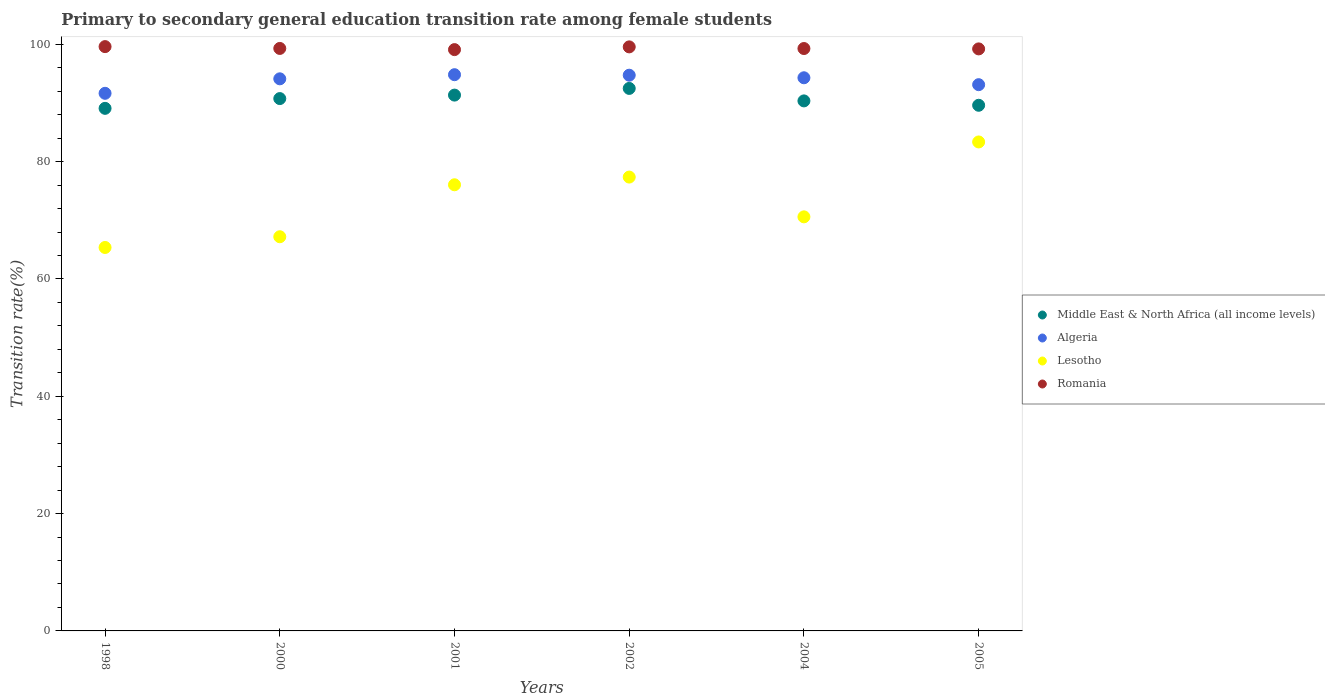What is the transition rate in Lesotho in 2000?
Your answer should be very brief. 67.2. Across all years, what is the maximum transition rate in Middle East & North Africa (all income levels)?
Keep it short and to the point. 92.48. Across all years, what is the minimum transition rate in Middle East & North Africa (all income levels)?
Keep it short and to the point. 89.09. In which year was the transition rate in Algeria maximum?
Give a very brief answer. 2001. In which year was the transition rate in Middle East & North Africa (all income levels) minimum?
Give a very brief answer. 1998. What is the total transition rate in Romania in the graph?
Your answer should be very brief. 596.08. What is the difference between the transition rate in Lesotho in 2001 and that in 2004?
Ensure brevity in your answer.  5.47. What is the difference between the transition rate in Algeria in 1998 and the transition rate in Romania in 2001?
Provide a short and direct response. -7.45. What is the average transition rate in Lesotho per year?
Your response must be concise. 73.32. In the year 2004, what is the difference between the transition rate in Romania and transition rate in Algeria?
Your answer should be very brief. 4.99. What is the ratio of the transition rate in Algeria in 1998 to that in 2000?
Ensure brevity in your answer.  0.97. Is the transition rate in Lesotho in 1998 less than that in 2005?
Your answer should be compact. Yes. What is the difference between the highest and the second highest transition rate in Algeria?
Provide a short and direct response. 0.09. What is the difference between the highest and the lowest transition rate in Lesotho?
Give a very brief answer. 17.99. In how many years, is the transition rate in Middle East & North Africa (all income levels) greater than the average transition rate in Middle East & North Africa (all income levels) taken over all years?
Offer a very short reply. 3. Is it the case that in every year, the sum of the transition rate in Algeria and transition rate in Romania  is greater than the sum of transition rate in Lesotho and transition rate in Middle East & North Africa (all income levels)?
Your response must be concise. Yes. Does the transition rate in Lesotho monotonically increase over the years?
Make the answer very short. No. Is the transition rate in Algeria strictly less than the transition rate in Middle East & North Africa (all income levels) over the years?
Ensure brevity in your answer.  No. How many dotlines are there?
Provide a short and direct response. 4. Does the graph contain grids?
Give a very brief answer. No. Where does the legend appear in the graph?
Your response must be concise. Center right. What is the title of the graph?
Ensure brevity in your answer.  Primary to secondary general education transition rate among female students. Does "Brunei Darussalam" appear as one of the legend labels in the graph?
Your response must be concise. No. What is the label or title of the X-axis?
Offer a terse response. Years. What is the label or title of the Y-axis?
Provide a succinct answer. Transition rate(%). What is the Transition rate(%) of Middle East & North Africa (all income levels) in 1998?
Provide a short and direct response. 89.09. What is the Transition rate(%) of Algeria in 1998?
Offer a terse response. 91.65. What is the Transition rate(%) of Lesotho in 1998?
Offer a very short reply. 65.37. What is the Transition rate(%) in Romania in 1998?
Keep it short and to the point. 99.61. What is the Transition rate(%) in Middle East & North Africa (all income levels) in 2000?
Provide a succinct answer. 90.75. What is the Transition rate(%) in Algeria in 2000?
Your response must be concise. 94.12. What is the Transition rate(%) in Lesotho in 2000?
Provide a succinct answer. 67.2. What is the Transition rate(%) of Romania in 2000?
Keep it short and to the point. 99.3. What is the Transition rate(%) of Middle East & North Africa (all income levels) in 2001?
Provide a succinct answer. 91.34. What is the Transition rate(%) of Algeria in 2001?
Provide a short and direct response. 94.82. What is the Transition rate(%) in Lesotho in 2001?
Provide a short and direct response. 76.06. What is the Transition rate(%) in Romania in 2001?
Your response must be concise. 99.1. What is the Transition rate(%) of Middle East & North Africa (all income levels) in 2002?
Your response must be concise. 92.48. What is the Transition rate(%) of Algeria in 2002?
Your response must be concise. 94.74. What is the Transition rate(%) in Lesotho in 2002?
Ensure brevity in your answer.  77.37. What is the Transition rate(%) in Romania in 2002?
Your response must be concise. 99.56. What is the Transition rate(%) in Middle East & North Africa (all income levels) in 2004?
Your response must be concise. 90.36. What is the Transition rate(%) in Algeria in 2004?
Give a very brief answer. 94.3. What is the Transition rate(%) in Lesotho in 2004?
Make the answer very short. 70.59. What is the Transition rate(%) of Romania in 2004?
Your answer should be compact. 99.28. What is the Transition rate(%) in Middle East & North Africa (all income levels) in 2005?
Provide a succinct answer. 89.61. What is the Transition rate(%) of Algeria in 2005?
Ensure brevity in your answer.  93.12. What is the Transition rate(%) of Lesotho in 2005?
Offer a very short reply. 83.36. What is the Transition rate(%) in Romania in 2005?
Provide a short and direct response. 99.22. Across all years, what is the maximum Transition rate(%) in Middle East & North Africa (all income levels)?
Offer a terse response. 92.48. Across all years, what is the maximum Transition rate(%) of Algeria?
Make the answer very short. 94.82. Across all years, what is the maximum Transition rate(%) in Lesotho?
Provide a short and direct response. 83.36. Across all years, what is the maximum Transition rate(%) of Romania?
Provide a short and direct response. 99.61. Across all years, what is the minimum Transition rate(%) in Middle East & North Africa (all income levels)?
Offer a very short reply. 89.09. Across all years, what is the minimum Transition rate(%) of Algeria?
Ensure brevity in your answer.  91.65. Across all years, what is the minimum Transition rate(%) in Lesotho?
Provide a succinct answer. 65.37. Across all years, what is the minimum Transition rate(%) of Romania?
Keep it short and to the point. 99.1. What is the total Transition rate(%) of Middle East & North Africa (all income levels) in the graph?
Your response must be concise. 543.64. What is the total Transition rate(%) of Algeria in the graph?
Your response must be concise. 562.75. What is the total Transition rate(%) of Lesotho in the graph?
Ensure brevity in your answer.  439.94. What is the total Transition rate(%) in Romania in the graph?
Provide a succinct answer. 596.08. What is the difference between the Transition rate(%) of Middle East & North Africa (all income levels) in 1998 and that in 2000?
Your answer should be compact. -1.66. What is the difference between the Transition rate(%) in Algeria in 1998 and that in 2000?
Offer a terse response. -2.47. What is the difference between the Transition rate(%) in Lesotho in 1998 and that in 2000?
Offer a very short reply. -1.83. What is the difference between the Transition rate(%) of Romania in 1998 and that in 2000?
Your answer should be very brief. 0.31. What is the difference between the Transition rate(%) in Middle East & North Africa (all income levels) in 1998 and that in 2001?
Your answer should be compact. -2.26. What is the difference between the Transition rate(%) in Algeria in 1998 and that in 2001?
Your response must be concise. -3.17. What is the difference between the Transition rate(%) in Lesotho in 1998 and that in 2001?
Your response must be concise. -10.69. What is the difference between the Transition rate(%) in Romania in 1998 and that in 2001?
Ensure brevity in your answer.  0.51. What is the difference between the Transition rate(%) of Middle East & North Africa (all income levels) in 1998 and that in 2002?
Give a very brief answer. -3.4. What is the difference between the Transition rate(%) of Algeria in 1998 and that in 2002?
Provide a short and direct response. -3.09. What is the difference between the Transition rate(%) of Lesotho in 1998 and that in 2002?
Your answer should be very brief. -12. What is the difference between the Transition rate(%) in Romania in 1998 and that in 2002?
Offer a very short reply. 0.05. What is the difference between the Transition rate(%) of Middle East & North Africa (all income levels) in 1998 and that in 2004?
Provide a short and direct response. -1.27. What is the difference between the Transition rate(%) in Algeria in 1998 and that in 2004?
Provide a succinct answer. -2.65. What is the difference between the Transition rate(%) of Lesotho in 1998 and that in 2004?
Offer a very short reply. -5.22. What is the difference between the Transition rate(%) in Romania in 1998 and that in 2004?
Provide a short and direct response. 0.33. What is the difference between the Transition rate(%) in Middle East & North Africa (all income levels) in 1998 and that in 2005?
Offer a terse response. -0.52. What is the difference between the Transition rate(%) of Algeria in 1998 and that in 2005?
Keep it short and to the point. -1.47. What is the difference between the Transition rate(%) of Lesotho in 1998 and that in 2005?
Make the answer very short. -17.99. What is the difference between the Transition rate(%) of Romania in 1998 and that in 2005?
Your answer should be compact. 0.39. What is the difference between the Transition rate(%) in Middle East & North Africa (all income levels) in 2000 and that in 2001?
Ensure brevity in your answer.  -0.59. What is the difference between the Transition rate(%) of Algeria in 2000 and that in 2001?
Offer a very short reply. -0.7. What is the difference between the Transition rate(%) of Lesotho in 2000 and that in 2001?
Provide a short and direct response. -8.86. What is the difference between the Transition rate(%) of Romania in 2000 and that in 2001?
Give a very brief answer. 0.2. What is the difference between the Transition rate(%) in Middle East & North Africa (all income levels) in 2000 and that in 2002?
Keep it short and to the point. -1.73. What is the difference between the Transition rate(%) in Algeria in 2000 and that in 2002?
Your answer should be very brief. -0.62. What is the difference between the Transition rate(%) in Lesotho in 2000 and that in 2002?
Your answer should be very brief. -10.17. What is the difference between the Transition rate(%) in Romania in 2000 and that in 2002?
Offer a very short reply. -0.26. What is the difference between the Transition rate(%) in Middle East & North Africa (all income levels) in 2000 and that in 2004?
Your answer should be very brief. 0.39. What is the difference between the Transition rate(%) of Algeria in 2000 and that in 2004?
Offer a terse response. -0.18. What is the difference between the Transition rate(%) of Lesotho in 2000 and that in 2004?
Your answer should be very brief. -3.39. What is the difference between the Transition rate(%) in Romania in 2000 and that in 2004?
Offer a very short reply. 0.02. What is the difference between the Transition rate(%) of Middle East & North Africa (all income levels) in 2000 and that in 2005?
Provide a short and direct response. 1.14. What is the difference between the Transition rate(%) of Algeria in 2000 and that in 2005?
Ensure brevity in your answer.  1. What is the difference between the Transition rate(%) of Lesotho in 2000 and that in 2005?
Give a very brief answer. -16.16. What is the difference between the Transition rate(%) in Romania in 2000 and that in 2005?
Your response must be concise. 0.08. What is the difference between the Transition rate(%) of Middle East & North Africa (all income levels) in 2001 and that in 2002?
Your answer should be compact. -1.14. What is the difference between the Transition rate(%) of Algeria in 2001 and that in 2002?
Provide a short and direct response. 0.09. What is the difference between the Transition rate(%) of Lesotho in 2001 and that in 2002?
Give a very brief answer. -1.31. What is the difference between the Transition rate(%) in Romania in 2001 and that in 2002?
Offer a very short reply. -0.47. What is the difference between the Transition rate(%) in Algeria in 2001 and that in 2004?
Provide a short and direct response. 0.53. What is the difference between the Transition rate(%) in Lesotho in 2001 and that in 2004?
Give a very brief answer. 5.47. What is the difference between the Transition rate(%) in Romania in 2001 and that in 2004?
Your response must be concise. -0.18. What is the difference between the Transition rate(%) in Middle East & North Africa (all income levels) in 2001 and that in 2005?
Make the answer very short. 1.73. What is the difference between the Transition rate(%) in Algeria in 2001 and that in 2005?
Keep it short and to the point. 1.7. What is the difference between the Transition rate(%) in Lesotho in 2001 and that in 2005?
Give a very brief answer. -7.3. What is the difference between the Transition rate(%) of Romania in 2001 and that in 2005?
Make the answer very short. -0.12. What is the difference between the Transition rate(%) of Middle East & North Africa (all income levels) in 2002 and that in 2004?
Your response must be concise. 2.13. What is the difference between the Transition rate(%) of Algeria in 2002 and that in 2004?
Offer a very short reply. 0.44. What is the difference between the Transition rate(%) in Lesotho in 2002 and that in 2004?
Provide a succinct answer. 6.78. What is the difference between the Transition rate(%) of Romania in 2002 and that in 2004?
Provide a short and direct response. 0.28. What is the difference between the Transition rate(%) in Middle East & North Africa (all income levels) in 2002 and that in 2005?
Your response must be concise. 2.87. What is the difference between the Transition rate(%) in Algeria in 2002 and that in 2005?
Keep it short and to the point. 1.61. What is the difference between the Transition rate(%) in Lesotho in 2002 and that in 2005?
Your answer should be compact. -5.99. What is the difference between the Transition rate(%) in Romania in 2002 and that in 2005?
Provide a succinct answer. 0.34. What is the difference between the Transition rate(%) of Middle East & North Africa (all income levels) in 2004 and that in 2005?
Offer a very short reply. 0.75. What is the difference between the Transition rate(%) in Algeria in 2004 and that in 2005?
Your answer should be very brief. 1.18. What is the difference between the Transition rate(%) of Lesotho in 2004 and that in 2005?
Keep it short and to the point. -12.77. What is the difference between the Transition rate(%) in Romania in 2004 and that in 2005?
Offer a very short reply. 0.06. What is the difference between the Transition rate(%) in Middle East & North Africa (all income levels) in 1998 and the Transition rate(%) in Algeria in 2000?
Make the answer very short. -5.03. What is the difference between the Transition rate(%) of Middle East & North Africa (all income levels) in 1998 and the Transition rate(%) of Lesotho in 2000?
Ensure brevity in your answer.  21.89. What is the difference between the Transition rate(%) of Middle East & North Africa (all income levels) in 1998 and the Transition rate(%) of Romania in 2000?
Offer a terse response. -10.21. What is the difference between the Transition rate(%) in Algeria in 1998 and the Transition rate(%) in Lesotho in 2000?
Provide a short and direct response. 24.45. What is the difference between the Transition rate(%) in Algeria in 1998 and the Transition rate(%) in Romania in 2000?
Your response must be concise. -7.65. What is the difference between the Transition rate(%) of Lesotho in 1998 and the Transition rate(%) of Romania in 2000?
Make the answer very short. -33.93. What is the difference between the Transition rate(%) in Middle East & North Africa (all income levels) in 1998 and the Transition rate(%) in Algeria in 2001?
Make the answer very short. -5.74. What is the difference between the Transition rate(%) in Middle East & North Africa (all income levels) in 1998 and the Transition rate(%) in Lesotho in 2001?
Provide a short and direct response. 13.03. What is the difference between the Transition rate(%) of Middle East & North Africa (all income levels) in 1998 and the Transition rate(%) of Romania in 2001?
Keep it short and to the point. -10.01. What is the difference between the Transition rate(%) of Algeria in 1998 and the Transition rate(%) of Lesotho in 2001?
Your answer should be very brief. 15.59. What is the difference between the Transition rate(%) of Algeria in 1998 and the Transition rate(%) of Romania in 2001?
Give a very brief answer. -7.45. What is the difference between the Transition rate(%) of Lesotho in 1998 and the Transition rate(%) of Romania in 2001?
Keep it short and to the point. -33.73. What is the difference between the Transition rate(%) in Middle East & North Africa (all income levels) in 1998 and the Transition rate(%) in Algeria in 2002?
Your answer should be compact. -5.65. What is the difference between the Transition rate(%) of Middle East & North Africa (all income levels) in 1998 and the Transition rate(%) of Lesotho in 2002?
Provide a succinct answer. 11.72. What is the difference between the Transition rate(%) of Middle East & North Africa (all income levels) in 1998 and the Transition rate(%) of Romania in 2002?
Make the answer very short. -10.48. What is the difference between the Transition rate(%) in Algeria in 1998 and the Transition rate(%) in Lesotho in 2002?
Make the answer very short. 14.28. What is the difference between the Transition rate(%) in Algeria in 1998 and the Transition rate(%) in Romania in 2002?
Ensure brevity in your answer.  -7.91. What is the difference between the Transition rate(%) in Lesotho in 1998 and the Transition rate(%) in Romania in 2002?
Your answer should be compact. -34.2. What is the difference between the Transition rate(%) of Middle East & North Africa (all income levels) in 1998 and the Transition rate(%) of Algeria in 2004?
Give a very brief answer. -5.21. What is the difference between the Transition rate(%) in Middle East & North Africa (all income levels) in 1998 and the Transition rate(%) in Lesotho in 2004?
Keep it short and to the point. 18.5. What is the difference between the Transition rate(%) in Middle East & North Africa (all income levels) in 1998 and the Transition rate(%) in Romania in 2004?
Give a very brief answer. -10.2. What is the difference between the Transition rate(%) in Algeria in 1998 and the Transition rate(%) in Lesotho in 2004?
Ensure brevity in your answer.  21.06. What is the difference between the Transition rate(%) in Algeria in 1998 and the Transition rate(%) in Romania in 2004?
Offer a very short reply. -7.63. What is the difference between the Transition rate(%) in Lesotho in 1998 and the Transition rate(%) in Romania in 2004?
Offer a very short reply. -33.92. What is the difference between the Transition rate(%) of Middle East & North Africa (all income levels) in 1998 and the Transition rate(%) of Algeria in 2005?
Provide a short and direct response. -4.04. What is the difference between the Transition rate(%) of Middle East & North Africa (all income levels) in 1998 and the Transition rate(%) of Lesotho in 2005?
Offer a terse response. 5.73. What is the difference between the Transition rate(%) in Middle East & North Africa (all income levels) in 1998 and the Transition rate(%) in Romania in 2005?
Offer a terse response. -10.13. What is the difference between the Transition rate(%) of Algeria in 1998 and the Transition rate(%) of Lesotho in 2005?
Provide a succinct answer. 8.29. What is the difference between the Transition rate(%) in Algeria in 1998 and the Transition rate(%) in Romania in 2005?
Offer a very short reply. -7.57. What is the difference between the Transition rate(%) of Lesotho in 1998 and the Transition rate(%) of Romania in 2005?
Provide a succinct answer. -33.85. What is the difference between the Transition rate(%) of Middle East & North Africa (all income levels) in 2000 and the Transition rate(%) of Algeria in 2001?
Provide a succinct answer. -4.07. What is the difference between the Transition rate(%) of Middle East & North Africa (all income levels) in 2000 and the Transition rate(%) of Lesotho in 2001?
Give a very brief answer. 14.69. What is the difference between the Transition rate(%) of Middle East & North Africa (all income levels) in 2000 and the Transition rate(%) of Romania in 2001?
Your response must be concise. -8.35. What is the difference between the Transition rate(%) of Algeria in 2000 and the Transition rate(%) of Lesotho in 2001?
Your answer should be very brief. 18.06. What is the difference between the Transition rate(%) in Algeria in 2000 and the Transition rate(%) in Romania in 2001?
Your response must be concise. -4.98. What is the difference between the Transition rate(%) in Lesotho in 2000 and the Transition rate(%) in Romania in 2001?
Your response must be concise. -31.9. What is the difference between the Transition rate(%) of Middle East & North Africa (all income levels) in 2000 and the Transition rate(%) of Algeria in 2002?
Provide a short and direct response. -3.98. What is the difference between the Transition rate(%) of Middle East & North Africa (all income levels) in 2000 and the Transition rate(%) of Lesotho in 2002?
Ensure brevity in your answer.  13.38. What is the difference between the Transition rate(%) in Middle East & North Africa (all income levels) in 2000 and the Transition rate(%) in Romania in 2002?
Keep it short and to the point. -8.81. What is the difference between the Transition rate(%) of Algeria in 2000 and the Transition rate(%) of Lesotho in 2002?
Make the answer very short. 16.75. What is the difference between the Transition rate(%) in Algeria in 2000 and the Transition rate(%) in Romania in 2002?
Your response must be concise. -5.44. What is the difference between the Transition rate(%) of Lesotho in 2000 and the Transition rate(%) of Romania in 2002?
Your answer should be very brief. -32.37. What is the difference between the Transition rate(%) of Middle East & North Africa (all income levels) in 2000 and the Transition rate(%) of Algeria in 2004?
Make the answer very short. -3.55. What is the difference between the Transition rate(%) in Middle East & North Africa (all income levels) in 2000 and the Transition rate(%) in Lesotho in 2004?
Provide a short and direct response. 20.16. What is the difference between the Transition rate(%) in Middle East & North Africa (all income levels) in 2000 and the Transition rate(%) in Romania in 2004?
Your answer should be very brief. -8.53. What is the difference between the Transition rate(%) of Algeria in 2000 and the Transition rate(%) of Lesotho in 2004?
Your response must be concise. 23.53. What is the difference between the Transition rate(%) in Algeria in 2000 and the Transition rate(%) in Romania in 2004?
Your answer should be compact. -5.16. What is the difference between the Transition rate(%) in Lesotho in 2000 and the Transition rate(%) in Romania in 2004?
Offer a terse response. -32.09. What is the difference between the Transition rate(%) in Middle East & North Africa (all income levels) in 2000 and the Transition rate(%) in Algeria in 2005?
Your response must be concise. -2.37. What is the difference between the Transition rate(%) in Middle East & North Africa (all income levels) in 2000 and the Transition rate(%) in Lesotho in 2005?
Offer a terse response. 7.39. What is the difference between the Transition rate(%) in Middle East & North Africa (all income levels) in 2000 and the Transition rate(%) in Romania in 2005?
Provide a short and direct response. -8.47. What is the difference between the Transition rate(%) in Algeria in 2000 and the Transition rate(%) in Lesotho in 2005?
Offer a very short reply. 10.76. What is the difference between the Transition rate(%) in Algeria in 2000 and the Transition rate(%) in Romania in 2005?
Your answer should be compact. -5.1. What is the difference between the Transition rate(%) in Lesotho in 2000 and the Transition rate(%) in Romania in 2005?
Give a very brief answer. -32.02. What is the difference between the Transition rate(%) of Middle East & North Africa (all income levels) in 2001 and the Transition rate(%) of Algeria in 2002?
Ensure brevity in your answer.  -3.39. What is the difference between the Transition rate(%) of Middle East & North Africa (all income levels) in 2001 and the Transition rate(%) of Lesotho in 2002?
Make the answer very short. 13.97. What is the difference between the Transition rate(%) in Middle East & North Africa (all income levels) in 2001 and the Transition rate(%) in Romania in 2002?
Provide a succinct answer. -8.22. What is the difference between the Transition rate(%) in Algeria in 2001 and the Transition rate(%) in Lesotho in 2002?
Make the answer very short. 17.45. What is the difference between the Transition rate(%) of Algeria in 2001 and the Transition rate(%) of Romania in 2002?
Give a very brief answer. -4.74. What is the difference between the Transition rate(%) in Lesotho in 2001 and the Transition rate(%) in Romania in 2002?
Provide a succinct answer. -23.51. What is the difference between the Transition rate(%) in Middle East & North Africa (all income levels) in 2001 and the Transition rate(%) in Algeria in 2004?
Keep it short and to the point. -2.95. What is the difference between the Transition rate(%) in Middle East & North Africa (all income levels) in 2001 and the Transition rate(%) in Lesotho in 2004?
Give a very brief answer. 20.75. What is the difference between the Transition rate(%) of Middle East & North Africa (all income levels) in 2001 and the Transition rate(%) of Romania in 2004?
Your response must be concise. -7.94. What is the difference between the Transition rate(%) of Algeria in 2001 and the Transition rate(%) of Lesotho in 2004?
Provide a short and direct response. 24.23. What is the difference between the Transition rate(%) in Algeria in 2001 and the Transition rate(%) in Romania in 2004?
Offer a very short reply. -4.46. What is the difference between the Transition rate(%) of Lesotho in 2001 and the Transition rate(%) of Romania in 2004?
Ensure brevity in your answer.  -23.23. What is the difference between the Transition rate(%) in Middle East & North Africa (all income levels) in 2001 and the Transition rate(%) in Algeria in 2005?
Make the answer very short. -1.78. What is the difference between the Transition rate(%) of Middle East & North Africa (all income levels) in 2001 and the Transition rate(%) of Lesotho in 2005?
Offer a terse response. 7.99. What is the difference between the Transition rate(%) of Middle East & North Africa (all income levels) in 2001 and the Transition rate(%) of Romania in 2005?
Offer a terse response. -7.88. What is the difference between the Transition rate(%) in Algeria in 2001 and the Transition rate(%) in Lesotho in 2005?
Provide a short and direct response. 11.47. What is the difference between the Transition rate(%) in Algeria in 2001 and the Transition rate(%) in Romania in 2005?
Provide a short and direct response. -4.4. What is the difference between the Transition rate(%) in Lesotho in 2001 and the Transition rate(%) in Romania in 2005?
Give a very brief answer. -23.16. What is the difference between the Transition rate(%) of Middle East & North Africa (all income levels) in 2002 and the Transition rate(%) of Algeria in 2004?
Your answer should be very brief. -1.81. What is the difference between the Transition rate(%) in Middle East & North Africa (all income levels) in 2002 and the Transition rate(%) in Lesotho in 2004?
Ensure brevity in your answer.  21.89. What is the difference between the Transition rate(%) in Middle East & North Africa (all income levels) in 2002 and the Transition rate(%) in Romania in 2004?
Provide a succinct answer. -6.8. What is the difference between the Transition rate(%) in Algeria in 2002 and the Transition rate(%) in Lesotho in 2004?
Offer a very short reply. 24.15. What is the difference between the Transition rate(%) of Algeria in 2002 and the Transition rate(%) of Romania in 2004?
Your answer should be very brief. -4.55. What is the difference between the Transition rate(%) of Lesotho in 2002 and the Transition rate(%) of Romania in 2004?
Your response must be concise. -21.91. What is the difference between the Transition rate(%) in Middle East & North Africa (all income levels) in 2002 and the Transition rate(%) in Algeria in 2005?
Make the answer very short. -0.64. What is the difference between the Transition rate(%) of Middle East & North Africa (all income levels) in 2002 and the Transition rate(%) of Lesotho in 2005?
Give a very brief answer. 9.13. What is the difference between the Transition rate(%) of Middle East & North Africa (all income levels) in 2002 and the Transition rate(%) of Romania in 2005?
Your answer should be very brief. -6.74. What is the difference between the Transition rate(%) in Algeria in 2002 and the Transition rate(%) in Lesotho in 2005?
Ensure brevity in your answer.  11.38. What is the difference between the Transition rate(%) in Algeria in 2002 and the Transition rate(%) in Romania in 2005?
Your answer should be very brief. -4.49. What is the difference between the Transition rate(%) of Lesotho in 2002 and the Transition rate(%) of Romania in 2005?
Give a very brief answer. -21.85. What is the difference between the Transition rate(%) of Middle East & North Africa (all income levels) in 2004 and the Transition rate(%) of Algeria in 2005?
Make the answer very short. -2.77. What is the difference between the Transition rate(%) in Middle East & North Africa (all income levels) in 2004 and the Transition rate(%) in Lesotho in 2005?
Provide a short and direct response. 7. What is the difference between the Transition rate(%) of Middle East & North Africa (all income levels) in 2004 and the Transition rate(%) of Romania in 2005?
Provide a short and direct response. -8.86. What is the difference between the Transition rate(%) of Algeria in 2004 and the Transition rate(%) of Lesotho in 2005?
Offer a very short reply. 10.94. What is the difference between the Transition rate(%) in Algeria in 2004 and the Transition rate(%) in Romania in 2005?
Offer a terse response. -4.92. What is the difference between the Transition rate(%) in Lesotho in 2004 and the Transition rate(%) in Romania in 2005?
Offer a very short reply. -28.63. What is the average Transition rate(%) of Middle East & North Africa (all income levels) per year?
Give a very brief answer. 90.61. What is the average Transition rate(%) in Algeria per year?
Offer a very short reply. 93.79. What is the average Transition rate(%) in Lesotho per year?
Make the answer very short. 73.32. What is the average Transition rate(%) in Romania per year?
Your response must be concise. 99.35. In the year 1998, what is the difference between the Transition rate(%) in Middle East & North Africa (all income levels) and Transition rate(%) in Algeria?
Provide a short and direct response. -2.56. In the year 1998, what is the difference between the Transition rate(%) of Middle East & North Africa (all income levels) and Transition rate(%) of Lesotho?
Ensure brevity in your answer.  23.72. In the year 1998, what is the difference between the Transition rate(%) of Middle East & North Africa (all income levels) and Transition rate(%) of Romania?
Keep it short and to the point. -10.52. In the year 1998, what is the difference between the Transition rate(%) of Algeria and Transition rate(%) of Lesotho?
Your answer should be very brief. 26.28. In the year 1998, what is the difference between the Transition rate(%) of Algeria and Transition rate(%) of Romania?
Your answer should be compact. -7.96. In the year 1998, what is the difference between the Transition rate(%) in Lesotho and Transition rate(%) in Romania?
Give a very brief answer. -34.24. In the year 2000, what is the difference between the Transition rate(%) of Middle East & North Africa (all income levels) and Transition rate(%) of Algeria?
Give a very brief answer. -3.37. In the year 2000, what is the difference between the Transition rate(%) in Middle East & North Africa (all income levels) and Transition rate(%) in Lesotho?
Offer a terse response. 23.55. In the year 2000, what is the difference between the Transition rate(%) in Middle East & North Africa (all income levels) and Transition rate(%) in Romania?
Your answer should be compact. -8.55. In the year 2000, what is the difference between the Transition rate(%) of Algeria and Transition rate(%) of Lesotho?
Provide a succinct answer. 26.92. In the year 2000, what is the difference between the Transition rate(%) in Algeria and Transition rate(%) in Romania?
Make the answer very short. -5.18. In the year 2000, what is the difference between the Transition rate(%) of Lesotho and Transition rate(%) of Romania?
Keep it short and to the point. -32.1. In the year 2001, what is the difference between the Transition rate(%) in Middle East & North Africa (all income levels) and Transition rate(%) in Algeria?
Provide a short and direct response. -3.48. In the year 2001, what is the difference between the Transition rate(%) of Middle East & North Africa (all income levels) and Transition rate(%) of Lesotho?
Offer a very short reply. 15.29. In the year 2001, what is the difference between the Transition rate(%) of Middle East & North Africa (all income levels) and Transition rate(%) of Romania?
Provide a succinct answer. -7.75. In the year 2001, what is the difference between the Transition rate(%) in Algeria and Transition rate(%) in Lesotho?
Offer a very short reply. 18.77. In the year 2001, what is the difference between the Transition rate(%) in Algeria and Transition rate(%) in Romania?
Your answer should be compact. -4.28. In the year 2001, what is the difference between the Transition rate(%) of Lesotho and Transition rate(%) of Romania?
Your response must be concise. -23.04. In the year 2002, what is the difference between the Transition rate(%) in Middle East & North Africa (all income levels) and Transition rate(%) in Algeria?
Keep it short and to the point. -2.25. In the year 2002, what is the difference between the Transition rate(%) of Middle East & North Africa (all income levels) and Transition rate(%) of Lesotho?
Ensure brevity in your answer.  15.11. In the year 2002, what is the difference between the Transition rate(%) of Middle East & North Africa (all income levels) and Transition rate(%) of Romania?
Ensure brevity in your answer.  -7.08. In the year 2002, what is the difference between the Transition rate(%) of Algeria and Transition rate(%) of Lesotho?
Keep it short and to the point. 17.37. In the year 2002, what is the difference between the Transition rate(%) in Algeria and Transition rate(%) in Romania?
Keep it short and to the point. -4.83. In the year 2002, what is the difference between the Transition rate(%) in Lesotho and Transition rate(%) in Romania?
Your answer should be compact. -22.19. In the year 2004, what is the difference between the Transition rate(%) of Middle East & North Africa (all income levels) and Transition rate(%) of Algeria?
Ensure brevity in your answer.  -3.94. In the year 2004, what is the difference between the Transition rate(%) of Middle East & North Africa (all income levels) and Transition rate(%) of Lesotho?
Give a very brief answer. 19.77. In the year 2004, what is the difference between the Transition rate(%) of Middle East & North Africa (all income levels) and Transition rate(%) of Romania?
Offer a very short reply. -8.93. In the year 2004, what is the difference between the Transition rate(%) of Algeria and Transition rate(%) of Lesotho?
Offer a terse response. 23.71. In the year 2004, what is the difference between the Transition rate(%) of Algeria and Transition rate(%) of Romania?
Your response must be concise. -4.99. In the year 2004, what is the difference between the Transition rate(%) in Lesotho and Transition rate(%) in Romania?
Your answer should be compact. -28.69. In the year 2005, what is the difference between the Transition rate(%) of Middle East & North Africa (all income levels) and Transition rate(%) of Algeria?
Make the answer very short. -3.51. In the year 2005, what is the difference between the Transition rate(%) in Middle East & North Africa (all income levels) and Transition rate(%) in Lesotho?
Offer a very short reply. 6.25. In the year 2005, what is the difference between the Transition rate(%) in Middle East & North Africa (all income levels) and Transition rate(%) in Romania?
Ensure brevity in your answer.  -9.61. In the year 2005, what is the difference between the Transition rate(%) in Algeria and Transition rate(%) in Lesotho?
Provide a succinct answer. 9.76. In the year 2005, what is the difference between the Transition rate(%) in Algeria and Transition rate(%) in Romania?
Offer a very short reply. -6.1. In the year 2005, what is the difference between the Transition rate(%) of Lesotho and Transition rate(%) of Romania?
Offer a very short reply. -15.86. What is the ratio of the Transition rate(%) in Middle East & North Africa (all income levels) in 1998 to that in 2000?
Ensure brevity in your answer.  0.98. What is the ratio of the Transition rate(%) in Algeria in 1998 to that in 2000?
Ensure brevity in your answer.  0.97. What is the ratio of the Transition rate(%) of Lesotho in 1998 to that in 2000?
Make the answer very short. 0.97. What is the ratio of the Transition rate(%) in Romania in 1998 to that in 2000?
Your answer should be very brief. 1. What is the ratio of the Transition rate(%) in Middle East & North Africa (all income levels) in 1998 to that in 2001?
Provide a succinct answer. 0.98. What is the ratio of the Transition rate(%) of Algeria in 1998 to that in 2001?
Offer a terse response. 0.97. What is the ratio of the Transition rate(%) of Lesotho in 1998 to that in 2001?
Provide a short and direct response. 0.86. What is the ratio of the Transition rate(%) in Middle East & North Africa (all income levels) in 1998 to that in 2002?
Your answer should be very brief. 0.96. What is the ratio of the Transition rate(%) in Algeria in 1998 to that in 2002?
Ensure brevity in your answer.  0.97. What is the ratio of the Transition rate(%) in Lesotho in 1998 to that in 2002?
Make the answer very short. 0.84. What is the ratio of the Transition rate(%) of Romania in 1998 to that in 2002?
Your response must be concise. 1. What is the ratio of the Transition rate(%) of Middle East & North Africa (all income levels) in 1998 to that in 2004?
Offer a very short reply. 0.99. What is the ratio of the Transition rate(%) in Algeria in 1998 to that in 2004?
Give a very brief answer. 0.97. What is the ratio of the Transition rate(%) of Lesotho in 1998 to that in 2004?
Make the answer very short. 0.93. What is the ratio of the Transition rate(%) of Romania in 1998 to that in 2004?
Make the answer very short. 1. What is the ratio of the Transition rate(%) of Middle East & North Africa (all income levels) in 1998 to that in 2005?
Make the answer very short. 0.99. What is the ratio of the Transition rate(%) of Algeria in 1998 to that in 2005?
Give a very brief answer. 0.98. What is the ratio of the Transition rate(%) of Lesotho in 1998 to that in 2005?
Offer a very short reply. 0.78. What is the ratio of the Transition rate(%) of Middle East & North Africa (all income levels) in 2000 to that in 2001?
Offer a very short reply. 0.99. What is the ratio of the Transition rate(%) of Algeria in 2000 to that in 2001?
Your response must be concise. 0.99. What is the ratio of the Transition rate(%) of Lesotho in 2000 to that in 2001?
Offer a very short reply. 0.88. What is the ratio of the Transition rate(%) of Middle East & North Africa (all income levels) in 2000 to that in 2002?
Your answer should be compact. 0.98. What is the ratio of the Transition rate(%) in Algeria in 2000 to that in 2002?
Your answer should be compact. 0.99. What is the ratio of the Transition rate(%) in Lesotho in 2000 to that in 2002?
Offer a terse response. 0.87. What is the ratio of the Transition rate(%) of Middle East & North Africa (all income levels) in 2000 to that in 2004?
Offer a terse response. 1. What is the ratio of the Transition rate(%) of Romania in 2000 to that in 2004?
Ensure brevity in your answer.  1. What is the ratio of the Transition rate(%) of Middle East & North Africa (all income levels) in 2000 to that in 2005?
Ensure brevity in your answer.  1.01. What is the ratio of the Transition rate(%) in Algeria in 2000 to that in 2005?
Make the answer very short. 1.01. What is the ratio of the Transition rate(%) of Lesotho in 2000 to that in 2005?
Keep it short and to the point. 0.81. What is the ratio of the Transition rate(%) of Romania in 2000 to that in 2005?
Your response must be concise. 1. What is the ratio of the Transition rate(%) of Middle East & North Africa (all income levels) in 2001 to that in 2002?
Offer a very short reply. 0.99. What is the ratio of the Transition rate(%) in Algeria in 2001 to that in 2002?
Make the answer very short. 1. What is the ratio of the Transition rate(%) of Lesotho in 2001 to that in 2002?
Offer a very short reply. 0.98. What is the ratio of the Transition rate(%) in Middle East & North Africa (all income levels) in 2001 to that in 2004?
Give a very brief answer. 1.01. What is the ratio of the Transition rate(%) in Algeria in 2001 to that in 2004?
Give a very brief answer. 1.01. What is the ratio of the Transition rate(%) of Lesotho in 2001 to that in 2004?
Ensure brevity in your answer.  1.08. What is the ratio of the Transition rate(%) of Middle East & North Africa (all income levels) in 2001 to that in 2005?
Your response must be concise. 1.02. What is the ratio of the Transition rate(%) in Algeria in 2001 to that in 2005?
Your answer should be compact. 1.02. What is the ratio of the Transition rate(%) of Lesotho in 2001 to that in 2005?
Provide a succinct answer. 0.91. What is the ratio of the Transition rate(%) of Middle East & North Africa (all income levels) in 2002 to that in 2004?
Offer a very short reply. 1.02. What is the ratio of the Transition rate(%) in Algeria in 2002 to that in 2004?
Offer a very short reply. 1. What is the ratio of the Transition rate(%) of Lesotho in 2002 to that in 2004?
Provide a short and direct response. 1.1. What is the ratio of the Transition rate(%) in Romania in 2002 to that in 2004?
Keep it short and to the point. 1. What is the ratio of the Transition rate(%) of Middle East & North Africa (all income levels) in 2002 to that in 2005?
Offer a terse response. 1.03. What is the ratio of the Transition rate(%) of Algeria in 2002 to that in 2005?
Provide a succinct answer. 1.02. What is the ratio of the Transition rate(%) in Lesotho in 2002 to that in 2005?
Your response must be concise. 0.93. What is the ratio of the Transition rate(%) of Romania in 2002 to that in 2005?
Provide a succinct answer. 1. What is the ratio of the Transition rate(%) of Middle East & North Africa (all income levels) in 2004 to that in 2005?
Your answer should be compact. 1.01. What is the ratio of the Transition rate(%) in Algeria in 2004 to that in 2005?
Your answer should be very brief. 1.01. What is the ratio of the Transition rate(%) of Lesotho in 2004 to that in 2005?
Offer a terse response. 0.85. What is the difference between the highest and the second highest Transition rate(%) in Middle East & North Africa (all income levels)?
Offer a terse response. 1.14. What is the difference between the highest and the second highest Transition rate(%) of Algeria?
Provide a succinct answer. 0.09. What is the difference between the highest and the second highest Transition rate(%) of Lesotho?
Offer a terse response. 5.99. What is the difference between the highest and the second highest Transition rate(%) in Romania?
Your response must be concise. 0.05. What is the difference between the highest and the lowest Transition rate(%) in Middle East & North Africa (all income levels)?
Give a very brief answer. 3.4. What is the difference between the highest and the lowest Transition rate(%) of Algeria?
Keep it short and to the point. 3.17. What is the difference between the highest and the lowest Transition rate(%) of Lesotho?
Your answer should be very brief. 17.99. What is the difference between the highest and the lowest Transition rate(%) of Romania?
Your answer should be very brief. 0.51. 